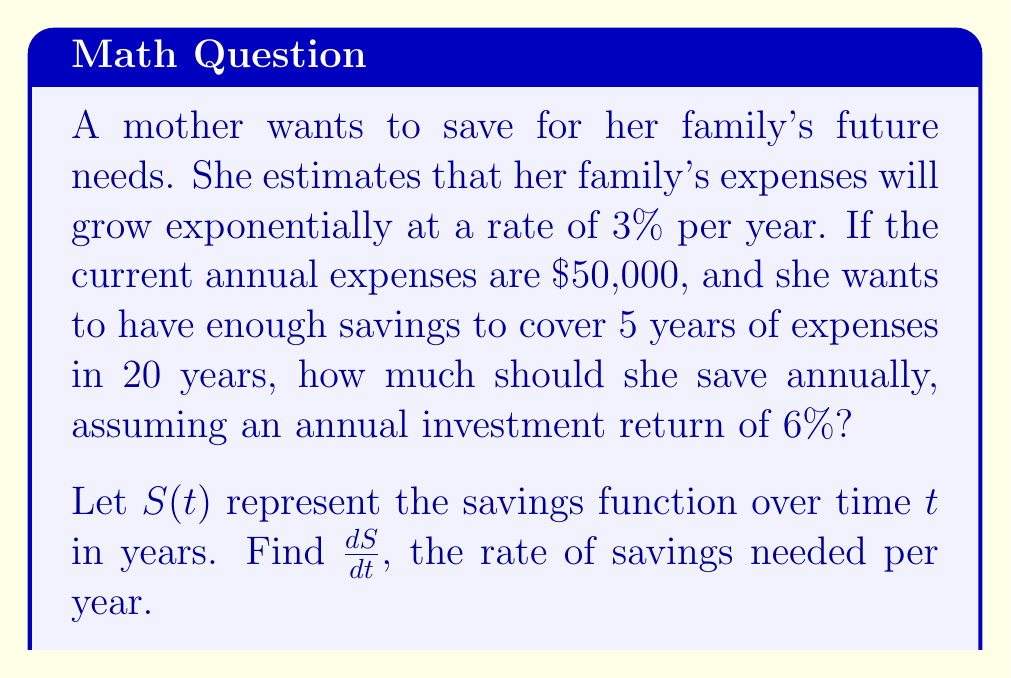Can you answer this question? Let's approach this step-by-step:

1) First, we need to calculate the future expenses in 20 years:
   $FE = 50000 \cdot e^{0.03 \cdot 20} \approx 90889.79$

2) The total amount needed in 20 years is:
   $Total = 90889.79 \cdot 5 = 454448.95$

3) We can use the compound interest formula to set up our equation:
   $S(t) \cdot (1 + 0.06)^{20} = 454448.95$

4) Solving for $S(t)$:
   $S(t) = \frac{454448.95}{(1.06)^{20}} \approx 141889.69$

5) Now, we need to find the rate of change of $S(t)$ with respect to time. We can do this by differentiating both sides of the equation with respect to $t$:

   $\frac{d}{dt}[S(t)] \cdot (1.06)^{20} = \frac{d}{dt}[141889.69]$

6) The right side becomes zero (as it's a constant), so:

   $\frac{dS}{dt} \cdot (1.06)^{20} = 0$

7) Solving for $\frac{dS}{dt}$:

   $\frac{dS}{dt} = \frac{141889.69}{20} \approx 7094.48$

This means the mother needs to save approximately $7,094.48 per year to reach her goal.
Answer: $\frac{dS}{dt} \approx 7094.48$ 